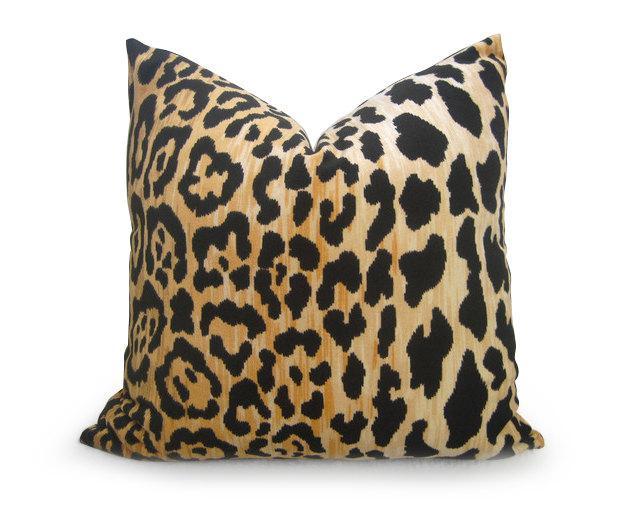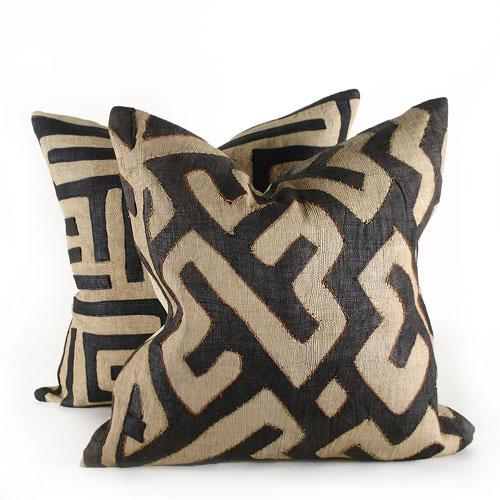The first image is the image on the left, the second image is the image on the right. Evaluate the accuracy of this statement regarding the images: "There are three pillows in the two images.". Is it true? Answer yes or no. Yes. 